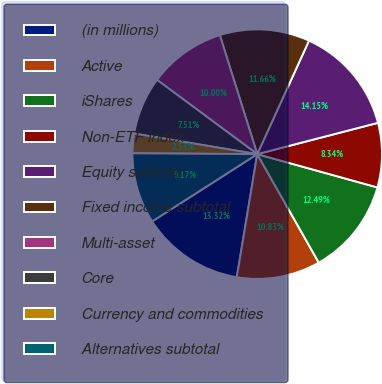<chart> <loc_0><loc_0><loc_500><loc_500><pie_chart><fcel>(in millions)<fcel>Active<fcel>iShares<fcel>Non-ETF index<fcel>Equity subtotal<fcel>Fixed income subtotal<fcel>Multi-asset<fcel>Core<fcel>Currency and commodities<fcel>Alternatives subtotal<nl><fcel>13.32%<fcel>10.83%<fcel>12.49%<fcel>8.34%<fcel>14.15%<fcel>11.66%<fcel>10.0%<fcel>7.51%<fcel>2.53%<fcel>9.17%<nl></chart> 